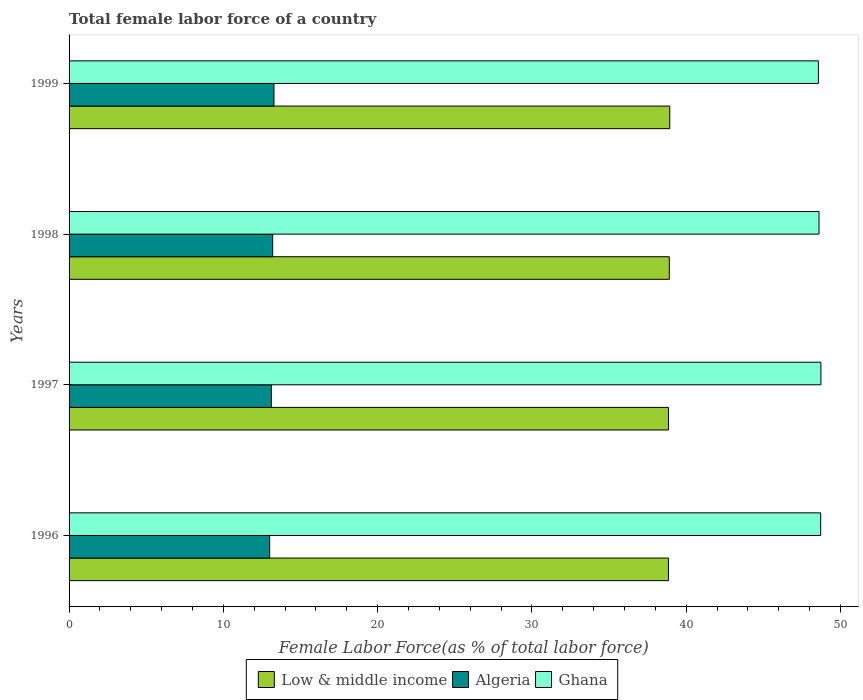How many groups of bars are there?
Offer a terse response. 4. Are the number of bars on each tick of the Y-axis equal?
Keep it short and to the point. Yes. How many bars are there on the 1st tick from the top?
Offer a terse response. 3. How many bars are there on the 4th tick from the bottom?
Offer a terse response. 3. What is the label of the 4th group of bars from the top?
Keep it short and to the point. 1996. What is the percentage of female labor force in Algeria in 1996?
Provide a succinct answer. 13. Across all years, what is the maximum percentage of female labor force in Algeria?
Offer a very short reply. 13.28. Across all years, what is the minimum percentage of female labor force in Low & middle income?
Your answer should be compact. 38.85. In which year was the percentage of female labor force in Ghana minimum?
Give a very brief answer. 1999. What is the total percentage of female labor force in Algeria in the graph?
Your response must be concise. 52.59. What is the difference between the percentage of female labor force in Algeria in 1997 and that in 1999?
Offer a terse response. -0.17. What is the difference between the percentage of female labor force in Algeria in 1996 and the percentage of female labor force in Low & middle income in 1999?
Your answer should be very brief. -25.93. What is the average percentage of female labor force in Ghana per year?
Keep it short and to the point. 48.66. In the year 1996, what is the difference between the percentage of female labor force in Ghana and percentage of female labor force in Algeria?
Make the answer very short. 35.71. What is the ratio of the percentage of female labor force in Low & middle income in 1996 to that in 1999?
Provide a succinct answer. 1. What is the difference between the highest and the second highest percentage of female labor force in Low & middle income?
Offer a very short reply. 0.03. What is the difference between the highest and the lowest percentage of female labor force in Algeria?
Give a very brief answer. 0.28. Is the sum of the percentage of female labor force in Low & middle income in 1996 and 1998 greater than the maximum percentage of female labor force in Ghana across all years?
Offer a terse response. Yes. What does the 2nd bar from the top in 1999 represents?
Provide a short and direct response. Algeria. What does the 1st bar from the bottom in 1999 represents?
Ensure brevity in your answer.  Low & middle income. Is it the case that in every year, the sum of the percentage of female labor force in Low & middle income and percentage of female labor force in Ghana is greater than the percentage of female labor force in Algeria?
Offer a very short reply. Yes. Are all the bars in the graph horizontal?
Keep it short and to the point. Yes. Are the values on the major ticks of X-axis written in scientific E-notation?
Provide a succinct answer. No. Does the graph contain any zero values?
Your answer should be very brief. No. Does the graph contain grids?
Offer a very short reply. No. What is the title of the graph?
Offer a very short reply. Total female labor force of a country. What is the label or title of the X-axis?
Provide a succinct answer. Female Labor Force(as % of total labor force). What is the label or title of the Y-axis?
Ensure brevity in your answer.  Years. What is the Female Labor Force(as % of total labor force) in Low & middle income in 1996?
Your answer should be compact. 38.85. What is the Female Labor Force(as % of total labor force) in Algeria in 1996?
Your response must be concise. 13. What is the Female Labor Force(as % of total labor force) in Ghana in 1996?
Provide a succinct answer. 48.71. What is the Female Labor Force(as % of total labor force) in Low & middle income in 1997?
Give a very brief answer. 38.85. What is the Female Labor Force(as % of total labor force) in Algeria in 1997?
Offer a very short reply. 13.11. What is the Female Labor Force(as % of total labor force) of Ghana in 1997?
Ensure brevity in your answer.  48.73. What is the Female Labor Force(as % of total labor force) in Low & middle income in 1998?
Your response must be concise. 38.91. What is the Female Labor Force(as % of total labor force) of Algeria in 1998?
Ensure brevity in your answer.  13.19. What is the Female Labor Force(as % of total labor force) of Ghana in 1998?
Your answer should be compact. 48.61. What is the Female Labor Force(as % of total labor force) of Low & middle income in 1999?
Ensure brevity in your answer.  38.93. What is the Female Labor Force(as % of total labor force) of Algeria in 1999?
Offer a very short reply. 13.28. What is the Female Labor Force(as % of total labor force) of Ghana in 1999?
Your answer should be compact. 48.57. Across all years, what is the maximum Female Labor Force(as % of total labor force) in Low & middle income?
Your answer should be very brief. 38.93. Across all years, what is the maximum Female Labor Force(as % of total labor force) of Algeria?
Offer a very short reply. 13.28. Across all years, what is the maximum Female Labor Force(as % of total labor force) of Ghana?
Make the answer very short. 48.73. Across all years, what is the minimum Female Labor Force(as % of total labor force) of Low & middle income?
Your answer should be compact. 38.85. Across all years, what is the minimum Female Labor Force(as % of total labor force) in Algeria?
Give a very brief answer. 13. Across all years, what is the minimum Female Labor Force(as % of total labor force) of Ghana?
Ensure brevity in your answer.  48.57. What is the total Female Labor Force(as % of total labor force) of Low & middle income in the graph?
Provide a succinct answer. 155.54. What is the total Female Labor Force(as % of total labor force) of Algeria in the graph?
Provide a succinct answer. 52.59. What is the total Female Labor Force(as % of total labor force) in Ghana in the graph?
Provide a succinct answer. 194.62. What is the difference between the Female Labor Force(as % of total labor force) of Low & middle income in 1996 and that in 1997?
Offer a terse response. -0. What is the difference between the Female Labor Force(as % of total labor force) of Algeria in 1996 and that in 1997?
Give a very brief answer. -0.11. What is the difference between the Female Labor Force(as % of total labor force) in Ghana in 1996 and that in 1997?
Your answer should be very brief. -0.02. What is the difference between the Female Labor Force(as % of total labor force) of Low & middle income in 1996 and that in 1998?
Offer a terse response. -0.06. What is the difference between the Female Labor Force(as % of total labor force) of Algeria in 1996 and that in 1998?
Offer a very short reply. -0.19. What is the difference between the Female Labor Force(as % of total labor force) in Ghana in 1996 and that in 1998?
Give a very brief answer. 0.11. What is the difference between the Female Labor Force(as % of total labor force) in Low & middle income in 1996 and that in 1999?
Give a very brief answer. -0.09. What is the difference between the Female Labor Force(as % of total labor force) in Algeria in 1996 and that in 1999?
Your answer should be compact. -0.28. What is the difference between the Female Labor Force(as % of total labor force) in Ghana in 1996 and that in 1999?
Give a very brief answer. 0.15. What is the difference between the Female Labor Force(as % of total labor force) in Low & middle income in 1997 and that in 1998?
Offer a terse response. -0.05. What is the difference between the Female Labor Force(as % of total labor force) in Algeria in 1997 and that in 1998?
Offer a very short reply. -0.08. What is the difference between the Female Labor Force(as % of total labor force) of Ghana in 1997 and that in 1998?
Offer a very short reply. 0.12. What is the difference between the Female Labor Force(as % of total labor force) in Low & middle income in 1997 and that in 1999?
Provide a succinct answer. -0.08. What is the difference between the Female Labor Force(as % of total labor force) in Algeria in 1997 and that in 1999?
Offer a very short reply. -0.17. What is the difference between the Female Labor Force(as % of total labor force) of Ghana in 1997 and that in 1999?
Provide a short and direct response. 0.16. What is the difference between the Female Labor Force(as % of total labor force) of Low & middle income in 1998 and that in 1999?
Provide a succinct answer. -0.03. What is the difference between the Female Labor Force(as % of total labor force) in Algeria in 1998 and that in 1999?
Your answer should be very brief. -0.09. What is the difference between the Female Labor Force(as % of total labor force) of Ghana in 1998 and that in 1999?
Provide a succinct answer. 0.04. What is the difference between the Female Labor Force(as % of total labor force) in Low & middle income in 1996 and the Female Labor Force(as % of total labor force) in Algeria in 1997?
Offer a very short reply. 25.74. What is the difference between the Female Labor Force(as % of total labor force) of Low & middle income in 1996 and the Female Labor Force(as % of total labor force) of Ghana in 1997?
Your response must be concise. -9.88. What is the difference between the Female Labor Force(as % of total labor force) in Algeria in 1996 and the Female Labor Force(as % of total labor force) in Ghana in 1997?
Your response must be concise. -35.73. What is the difference between the Female Labor Force(as % of total labor force) of Low & middle income in 1996 and the Female Labor Force(as % of total labor force) of Algeria in 1998?
Give a very brief answer. 25.65. What is the difference between the Female Labor Force(as % of total labor force) of Low & middle income in 1996 and the Female Labor Force(as % of total labor force) of Ghana in 1998?
Your answer should be very brief. -9.76. What is the difference between the Female Labor Force(as % of total labor force) of Algeria in 1996 and the Female Labor Force(as % of total labor force) of Ghana in 1998?
Provide a succinct answer. -35.61. What is the difference between the Female Labor Force(as % of total labor force) of Low & middle income in 1996 and the Female Labor Force(as % of total labor force) of Algeria in 1999?
Make the answer very short. 25.57. What is the difference between the Female Labor Force(as % of total labor force) in Low & middle income in 1996 and the Female Labor Force(as % of total labor force) in Ghana in 1999?
Offer a very short reply. -9.72. What is the difference between the Female Labor Force(as % of total labor force) in Algeria in 1996 and the Female Labor Force(as % of total labor force) in Ghana in 1999?
Your answer should be very brief. -35.57. What is the difference between the Female Labor Force(as % of total labor force) of Low & middle income in 1997 and the Female Labor Force(as % of total labor force) of Algeria in 1998?
Provide a succinct answer. 25.66. What is the difference between the Female Labor Force(as % of total labor force) in Low & middle income in 1997 and the Female Labor Force(as % of total labor force) in Ghana in 1998?
Your response must be concise. -9.76. What is the difference between the Female Labor Force(as % of total labor force) of Algeria in 1997 and the Female Labor Force(as % of total labor force) of Ghana in 1998?
Your answer should be very brief. -35.5. What is the difference between the Female Labor Force(as % of total labor force) in Low & middle income in 1997 and the Female Labor Force(as % of total labor force) in Algeria in 1999?
Your answer should be very brief. 25.57. What is the difference between the Female Labor Force(as % of total labor force) of Low & middle income in 1997 and the Female Labor Force(as % of total labor force) of Ghana in 1999?
Your answer should be compact. -9.72. What is the difference between the Female Labor Force(as % of total labor force) in Algeria in 1997 and the Female Labor Force(as % of total labor force) in Ghana in 1999?
Give a very brief answer. -35.46. What is the difference between the Female Labor Force(as % of total labor force) in Low & middle income in 1998 and the Female Labor Force(as % of total labor force) in Algeria in 1999?
Offer a very short reply. 25.62. What is the difference between the Female Labor Force(as % of total labor force) in Low & middle income in 1998 and the Female Labor Force(as % of total labor force) in Ghana in 1999?
Provide a succinct answer. -9.66. What is the difference between the Female Labor Force(as % of total labor force) of Algeria in 1998 and the Female Labor Force(as % of total labor force) of Ghana in 1999?
Make the answer very short. -35.37. What is the average Female Labor Force(as % of total labor force) of Low & middle income per year?
Keep it short and to the point. 38.89. What is the average Female Labor Force(as % of total labor force) in Algeria per year?
Your answer should be compact. 13.15. What is the average Female Labor Force(as % of total labor force) in Ghana per year?
Ensure brevity in your answer.  48.66. In the year 1996, what is the difference between the Female Labor Force(as % of total labor force) in Low & middle income and Female Labor Force(as % of total labor force) in Algeria?
Give a very brief answer. 25.85. In the year 1996, what is the difference between the Female Labor Force(as % of total labor force) in Low & middle income and Female Labor Force(as % of total labor force) in Ghana?
Your answer should be compact. -9.87. In the year 1996, what is the difference between the Female Labor Force(as % of total labor force) in Algeria and Female Labor Force(as % of total labor force) in Ghana?
Offer a very short reply. -35.71. In the year 1997, what is the difference between the Female Labor Force(as % of total labor force) in Low & middle income and Female Labor Force(as % of total labor force) in Algeria?
Give a very brief answer. 25.74. In the year 1997, what is the difference between the Female Labor Force(as % of total labor force) of Low & middle income and Female Labor Force(as % of total labor force) of Ghana?
Offer a terse response. -9.88. In the year 1997, what is the difference between the Female Labor Force(as % of total labor force) of Algeria and Female Labor Force(as % of total labor force) of Ghana?
Give a very brief answer. -35.62. In the year 1998, what is the difference between the Female Labor Force(as % of total labor force) of Low & middle income and Female Labor Force(as % of total labor force) of Algeria?
Offer a terse response. 25.71. In the year 1998, what is the difference between the Female Labor Force(as % of total labor force) of Low & middle income and Female Labor Force(as % of total labor force) of Ghana?
Give a very brief answer. -9.7. In the year 1998, what is the difference between the Female Labor Force(as % of total labor force) in Algeria and Female Labor Force(as % of total labor force) in Ghana?
Keep it short and to the point. -35.41. In the year 1999, what is the difference between the Female Labor Force(as % of total labor force) of Low & middle income and Female Labor Force(as % of total labor force) of Algeria?
Ensure brevity in your answer.  25.65. In the year 1999, what is the difference between the Female Labor Force(as % of total labor force) in Low & middle income and Female Labor Force(as % of total labor force) in Ghana?
Your response must be concise. -9.63. In the year 1999, what is the difference between the Female Labor Force(as % of total labor force) of Algeria and Female Labor Force(as % of total labor force) of Ghana?
Keep it short and to the point. -35.29. What is the ratio of the Female Labor Force(as % of total labor force) of Low & middle income in 1996 to that in 1997?
Ensure brevity in your answer.  1. What is the ratio of the Female Labor Force(as % of total labor force) of Algeria in 1996 to that in 1997?
Make the answer very short. 0.99. What is the ratio of the Female Labor Force(as % of total labor force) in Ghana in 1996 to that in 1997?
Keep it short and to the point. 1. What is the ratio of the Female Labor Force(as % of total labor force) in Low & middle income in 1996 to that in 1998?
Ensure brevity in your answer.  1. What is the ratio of the Female Labor Force(as % of total labor force) in Algeria in 1996 to that in 1998?
Offer a very short reply. 0.99. What is the ratio of the Female Labor Force(as % of total labor force) of Algeria in 1996 to that in 1999?
Keep it short and to the point. 0.98. What is the ratio of the Female Labor Force(as % of total labor force) in Ghana in 1997 to that in 1998?
Provide a succinct answer. 1. What is the ratio of the Female Labor Force(as % of total labor force) of Low & middle income in 1997 to that in 1999?
Make the answer very short. 1. What is the ratio of the Female Labor Force(as % of total labor force) of Algeria in 1997 to that in 1999?
Your response must be concise. 0.99. What is the ratio of the Female Labor Force(as % of total labor force) in Ghana in 1997 to that in 1999?
Provide a succinct answer. 1. What is the ratio of the Female Labor Force(as % of total labor force) in Low & middle income in 1998 to that in 1999?
Ensure brevity in your answer.  1. What is the ratio of the Female Labor Force(as % of total labor force) in Algeria in 1998 to that in 1999?
Make the answer very short. 0.99. What is the difference between the highest and the second highest Female Labor Force(as % of total labor force) in Low & middle income?
Give a very brief answer. 0.03. What is the difference between the highest and the second highest Female Labor Force(as % of total labor force) in Algeria?
Ensure brevity in your answer.  0.09. What is the difference between the highest and the second highest Female Labor Force(as % of total labor force) in Ghana?
Offer a very short reply. 0.02. What is the difference between the highest and the lowest Female Labor Force(as % of total labor force) of Low & middle income?
Offer a terse response. 0.09. What is the difference between the highest and the lowest Female Labor Force(as % of total labor force) of Algeria?
Your response must be concise. 0.28. What is the difference between the highest and the lowest Female Labor Force(as % of total labor force) of Ghana?
Your response must be concise. 0.16. 